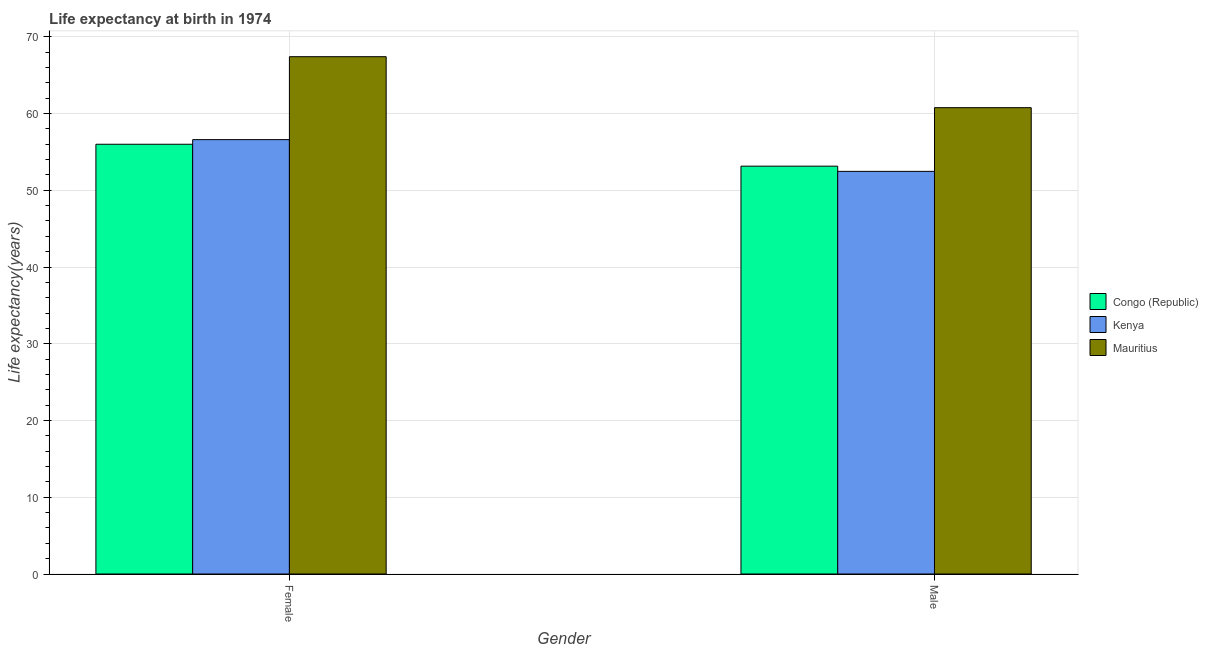Are the number of bars per tick equal to the number of legend labels?
Give a very brief answer. Yes. Are the number of bars on each tick of the X-axis equal?
Make the answer very short. Yes. How many bars are there on the 2nd tick from the left?
Your answer should be very brief. 3. How many bars are there on the 2nd tick from the right?
Offer a very short reply. 3. What is the label of the 1st group of bars from the left?
Keep it short and to the point. Female. What is the life expectancy(female) in Congo (Republic)?
Your answer should be very brief. 55.99. Across all countries, what is the maximum life expectancy(male)?
Your answer should be compact. 60.76. Across all countries, what is the minimum life expectancy(male)?
Offer a very short reply. 52.46. In which country was the life expectancy(male) maximum?
Your answer should be compact. Mauritius. In which country was the life expectancy(female) minimum?
Make the answer very short. Congo (Republic). What is the total life expectancy(male) in the graph?
Provide a succinct answer. 166.36. What is the difference between the life expectancy(male) in Mauritius and that in Congo (Republic)?
Give a very brief answer. 7.62. What is the difference between the life expectancy(male) in Congo (Republic) and the life expectancy(female) in Mauritius?
Your answer should be compact. -14.26. What is the average life expectancy(female) per country?
Your answer should be compact. 60. What is the difference between the life expectancy(male) and life expectancy(female) in Congo (Republic)?
Keep it short and to the point. -2.85. In how many countries, is the life expectancy(female) greater than 16 years?
Offer a terse response. 3. What is the ratio of the life expectancy(female) in Mauritius to that in Congo (Republic)?
Your answer should be very brief. 1.2. In how many countries, is the life expectancy(female) greater than the average life expectancy(female) taken over all countries?
Give a very brief answer. 1. What does the 3rd bar from the left in Male represents?
Give a very brief answer. Mauritius. What does the 1st bar from the right in Female represents?
Offer a very short reply. Mauritius. How many bars are there?
Your response must be concise. 6. What is the difference between two consecutive major ticks on the Y-axis?
Offer a very short reply. 10. Are the values on the major ticks of Y-axis written in scientific E-notation?
Offer a terse response. No. Does the graph contain any zero values?
Give a very brief answer. No. Does the graph contain grids?
Give a very brief answer. Yes. How are the legend labels stacked?
Your response must be concise. Vertical. What is the title of the graph?
Offer a very short reply. Life expectancy at birth in 1974. Does "Iraq" appear as one of the legend labels in the graph?
Ensure brevity in your answer.  No. What is the label or title of the Y-axis?
Your answer should be very brief. Life expectancy(years). What is the Life expectancy(years) in Congo (Republic) in Female?
Provide a succinct answer. 55.99. What is the Life expectancy(years) of Kenya in Female?
Offer a very short reply. 56.6. What is the Life expectancy(years) in Mauritius in Female?
Provide a succinct answer. 67.4. What is the Life expectancy(years) of Congo (Republic) in Male?
Your response must be concise. 53.14. What is the Life expectancy(years) in Kenya in Male?
Your answer should be compact. 52.46. What is the Life expectancy(years) of Mauritius in Male?
Keep it short and to the point. 60.76. Across all Gender, what is the maximum Life expectancy(years) in Congo (Republic)?
Offer a very short reply. 55.99. Across all Gender, what is the maximum Life expectancy(years) of Kenya?
Keep it short and to the point. 56.6. Across all Gender, what is the maximum Life expectancy(years) of Mauritius?
Make the answer very short. 67.4. Across all Gender, what is the minimum Life expectancy(years) in Congo (Republic)?
Offer a terse response. 53.14. Across all Gender, what is the minimum Life expectancy(years) of Kenya?
Offer a terse response. 52.46. Across all Gender, what is the minimum Life expectancy(years) of Mauritius?
Offer a very short reply. 60.76. What is the total Life expectancy(years) of Congo (Republic) in the graph?
Provide a succinct answer. 109.13. What is the total Life expectancy(years) of Kenya in the graph?
Offer a very short reply. 109.06. What is the total Life expectancy(years) of Mauritius in the graph?
Your answer should be compact. 128.16. What is the difference between the Life expectancy(years) in Congo (Republic) in Female and that in Male?
Make the answer very short. 2.85. What is the difference between the Life expectancy(years) of Kenya in Female and that in Male?
Keep it short and to the point. 4.13. What is the difference between the Life expectancy(years) of Mauritius in Female and that in Male?
Offer a terse response. 6.64. What is the difference between the Life expectancy(years) of Congo (Republic) in Female and the Life expectancy(years) of Kenya in Male?
Your answer should be very brief. 3.53. What is the difference between the Life expectancy(years) in Congo (Republic) in Female and the Life expectancy(years) in Mauritius in Male?
Give a very brief answer. -4.77. What is the difference between the Life expectancy(years) in Kenya in Female and the Life expectancy(years) in Mauritius in Male?
Keep it short and to the point. -4.16. What is the average Life expectancy(years) in Congo (Republic) per Gender?
Your answer should be very brief. 54.57. What is the average Life expectancy(years) of Kenya per Gender?
Your answer should be compact. 54.53. What is the average Life expectancy(years) in Mauritius per Gender?
Your answer should be compact. 64.08. What is the difference between the Life expectancy(years) of Congo (Republic) and Life expectancy(years) of Kenya in Female?
Offer a very short reply. -0.6. What is the difference between the Life expectancy(years) of Congo (Republic) and Life expectancy(years) of Mauritius in Female?
Offer a terse response. -11.41. What is the difference between the Life expectancy(years) in Kenya and Life expectancy(years) in Mauritius in Female?
Make the answer very short. -10.81. What is the difference between the Life expectancy(years) of Congo (Republic) and Life expectancy(years) of Kenya in Male?
Make the answer very short. 0.68. What is the difference between the Life expectancy(years) in Congo (Republic) and Life expectancy(years) in Mauritius in Male?
Offer a very short reply. -7.62. What is the difference between the Life expectancy(years) in Kenya and Life expectancy(years) in Mauritius in Male?
Make the answer very short. -8.3. What is the ratio of the Life expectancy(years) in Congo (Republic) in Female to that in Male?
Make the answer very short. 1.05. What is the ratio of the Life expectancy(years) in Kenya in Female to that in Male?
Give a very brief answer. 1.08. What is the ratio of the Life expectancy(years) in Mauritius in Female to that in Male?
Your answer should be very brief. 1.11. What is the difference between the highest and the second highest Life expectancy(years) of Congo (Republic)?
Make the answer very short. 2.85. What is the difference between the highest and the second highest Life expectancy(years) in Kenya?
Give a very brief answer. 4.13. What is the difference between the highest and the second highest Life expectancy(years) in Mauritius?
Offer a very short reply. 6.64. What is the difference between the highest and the lowest Life expectancy(years) in Congo (Republic)?
Offer a very short reply. 2.85. What is the difference between the highest and the lowest Life expectancy(years) in Kenya?
Give a very brief answer. 4.13. What is the difference between the highest and the lowest Life expectancy(years) in Mauritius?
Offer a terse response. 6.64. 